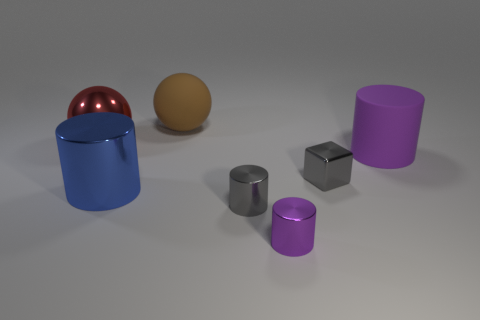Subtract all gray cylinders. How many cylinders are left? 3 Add 1 blue shiny objects. How many objects exist? 8 Subtract all brown spheres. How many spheres are left? 1 Subtract all purple cubes. How many purple cylinders are left? 2 Subtract all cylinders. How many objects are left? 3 Subtract all purple matte cylinders. Subtract all large brown matte things. How many objects are left? 5 Add 4 tiny gray objects. How many tiny gray objects are left? 6 Add 1 big cyan matte cylinders. How many big cyan matte cylinders exist? 1 Subtract 1 gray blocks. How many objects are left? 6 Subtract all green balls. Subtract all red cylinders. How many balls are left? 2 